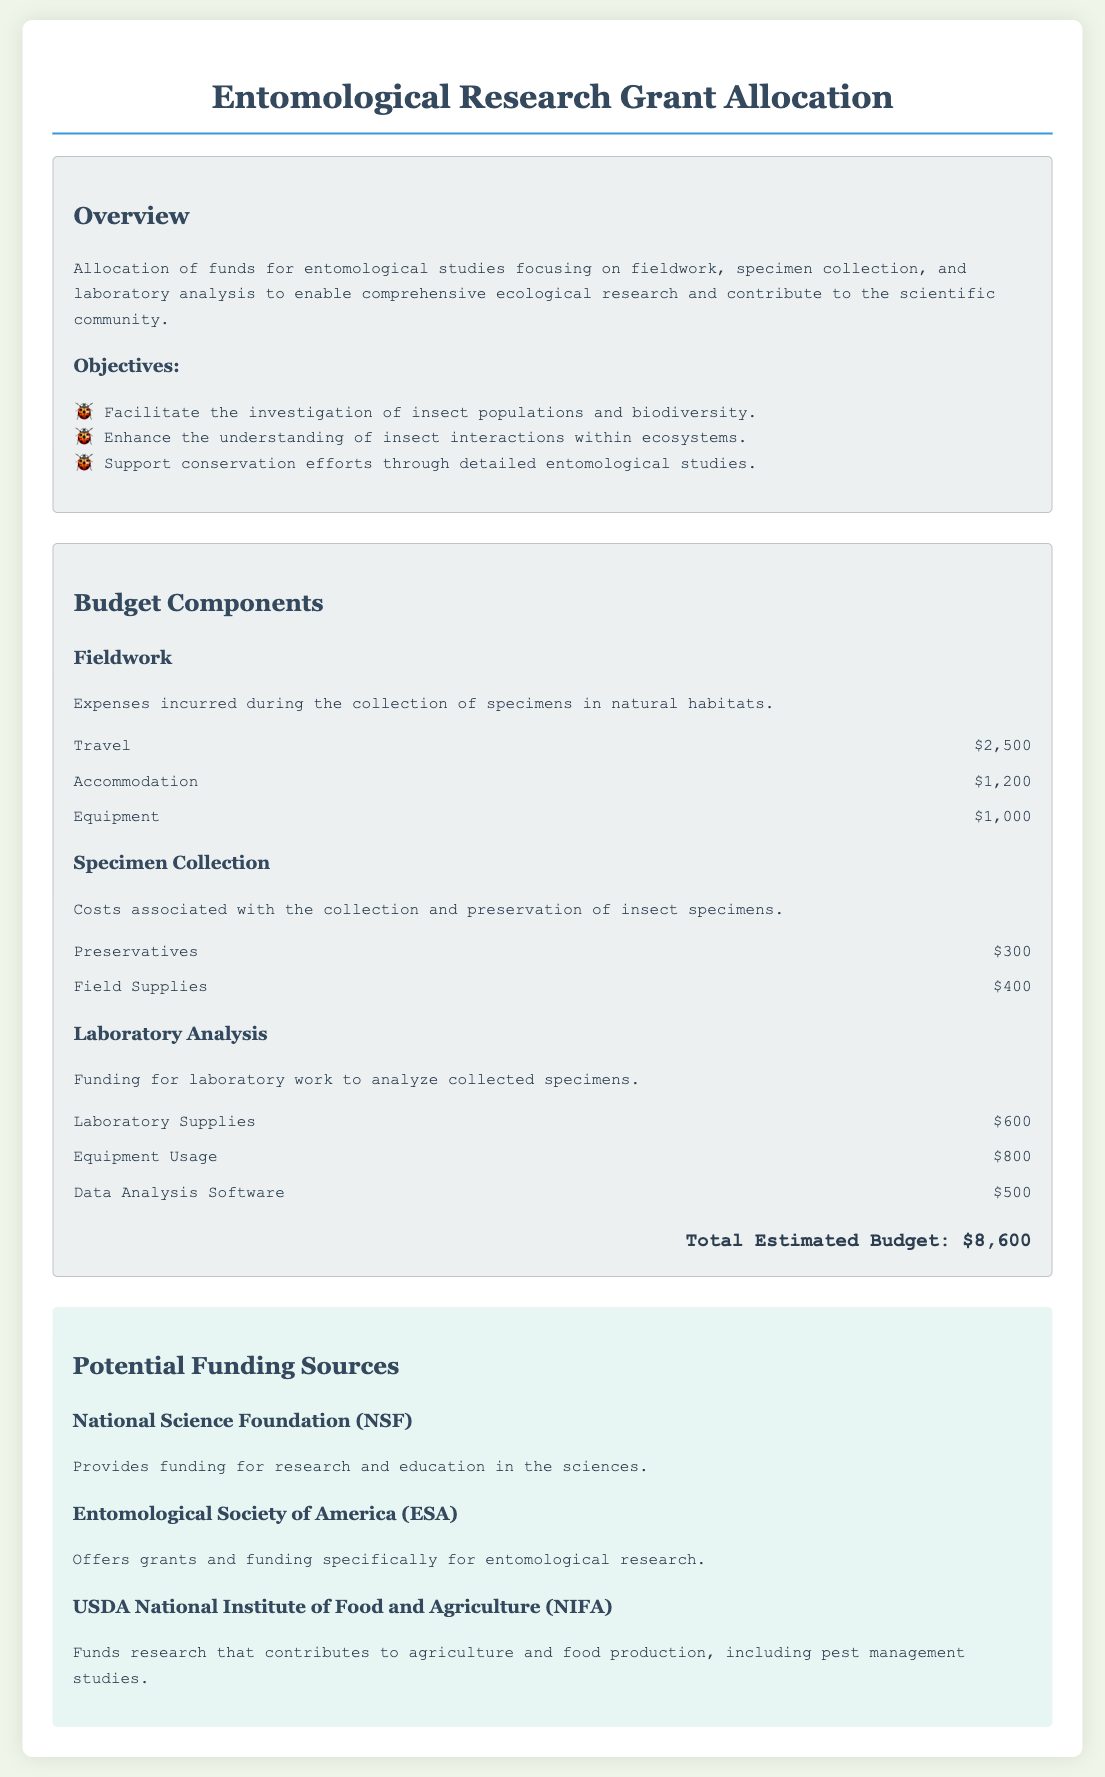What is the total estimated budget? The total estimated budget is stated at the end of the budget components section, summarizing all expenditures, which is $8,600.
Answer: $8,600 What is the funding amount for travel in the fieldwork section? The travel amount is specified under the fieldwork budget component, which is $2,500.
Answer: $2,500 Which organization provides funding for research and education in the sciences? The National Science Foundation is mentioned in the potential funding sources as providing such funding.
Answer: National Science Foundation How much is allocated for laboratory supplies in the laboratory analysis section? The budget item under laboratory analysis specifically states the amount for laboratory supplies is $600.
Answer: $600 What is the purpose of this document? The purpose of the document is described in the overview section, emphasizing allocation of funds for entomological studies.
Answer: Allocation of funds for entomological studies How many objectives are listed for the entomological research? The number of objectives can be counted from the objectives section, where three objectives are mentioned.
Answer: Three What expense category does 'Equipment Usage' fall under? The category 'Equipment Usage' is found in the laboratory analysis section of the budget components.
Answer: Laboratory Analysis Which funding source is focused specifically on entomological research? The Entomological Society of America is identified as focusing specifically on entomological research funding in the document.
Answer: Entomological Society of America 